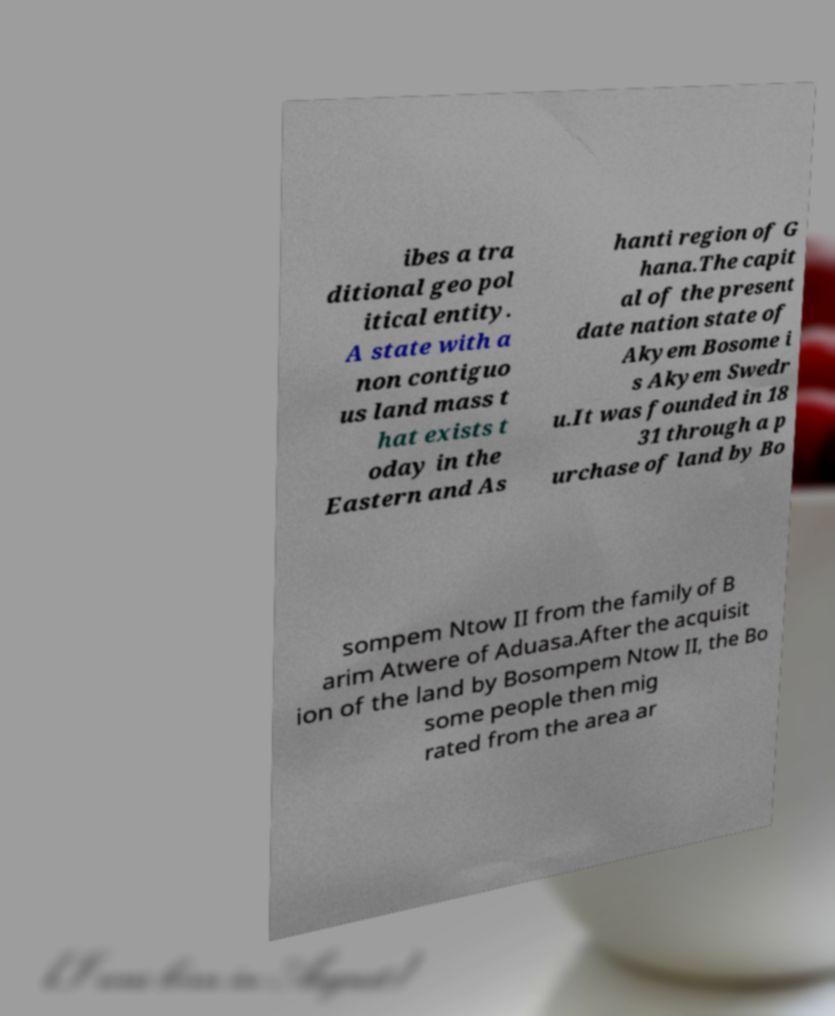There's text embedded in this image that I need extracted. Can you transcribe it verbatim? ibes a tra ditional geo pol itical entity. A state with a non contiguo us land mass t hat exists t oday in the Eastern and As hanti region of G hana.The capit al of the present date nation state of Akyem Bosome i s Akyem Swedr u.It was founded in 18 31 through a p urchase of land by Bo sompem Ntow II from the family of B arim Atwere of Aduasa.After the acquisit ion of the land by Bosompem Ntow II, the Bo some people then mig rated from the area ar 